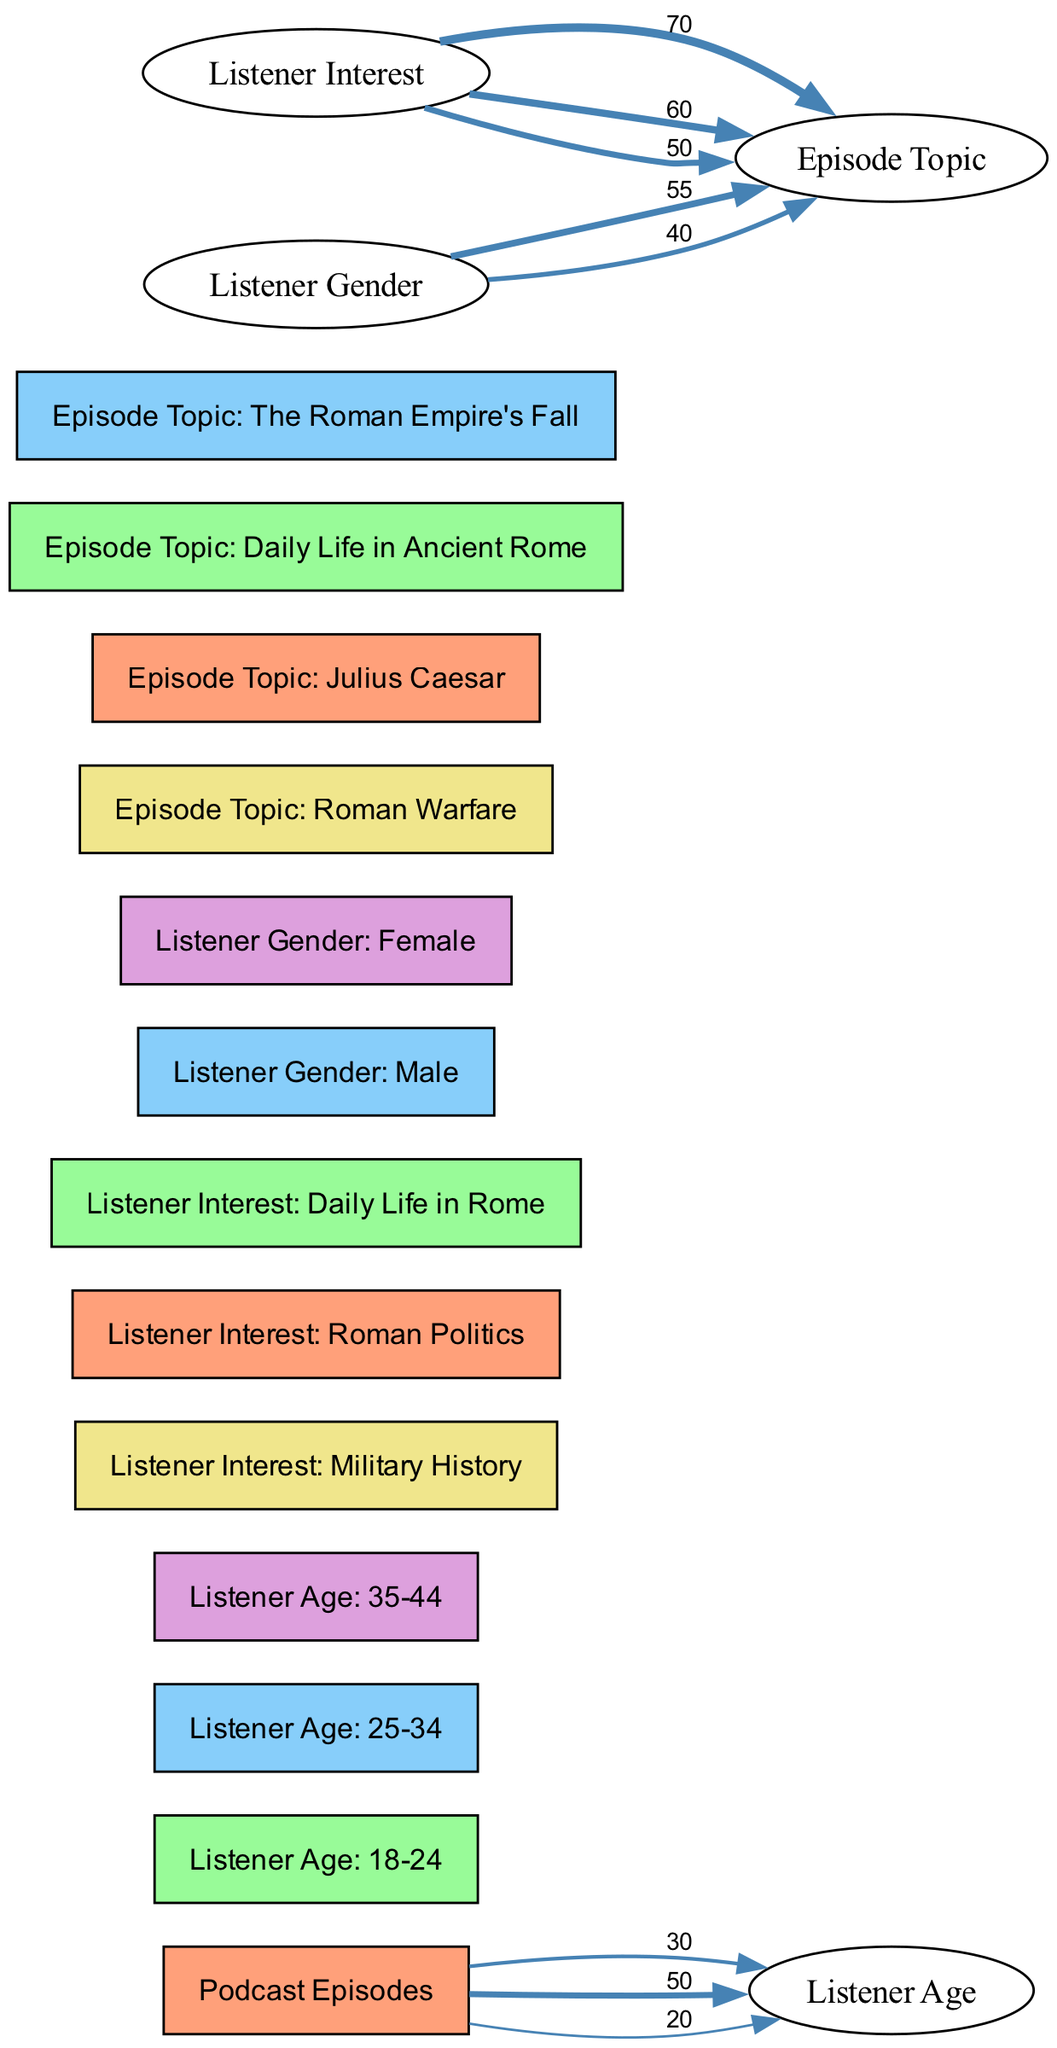What is the total number of listeners aged 25-34? The diagram shows a direct connection between "Podcast Episodes" and "Listener Age: 25-34", with a value of 50. Therefore, the total number of listeners in this age group is represented by this value.
Answer: 50 Which episode topic has the highest interest from listeners of military history? The flow from "Listener Interest: Military History" to "Episode Topic: Roman Warfare" has the highest value of 70, indicating that this episode topic attracts the most interest from military history listeners.
Answer: Roman Warfare What percentage of listeners aged 18-24 are interested in military history? To find out the percentage, first note the value of listeners aged 18-24 is 30 and the value from military history to Roman Warfare is 70. Since the total number of listeners is presumably the sum of several listener groups, we can typically estimate the interest by simply considering the age group value against the context. In this case, however, due to lack of absolute total listeners given, we can conclude from the diagram directly that not all listeners in any age group may be military history lovers, thus resulting in a descriptive observation rather than calculating a percentage.
Answer: Not determinable Which listener demographic is most interested in the topic "The Roman Empire's Fall"? Observing the flow from "Listener Gender: Male" to "Episode Topic: The Roman Empire's Fall" with a value of 55 indicates this gender group has the highest connection to the topic compared to the connection flows from other demographics.
Answer: Male What is the value linking "Listener Gender: Female" to "Episode Topic: Julius Caesar"? The link from "Listener Gender: Female" to "Episode Topic: Julius Caesar" has a value of 40, indicating the number of female listeners interested in that episode topic.
Answer: 40 Which age group has the least representation in the listener demographic? Focusing on the connections between "Podcast Episodes" and listener ages, the node "Listener Age: 35-44" has the lowest value of 20, indicating fewer listeners belonging to this age group.
Answer: 35-44 How does listener interest in "Daily Life in Rome" connect to episode preferences? The connection from "Listener Interest: Daily Life in Rome" to "Episode Topic: Daily Life in Ancient Rome" with a value of 50 shows a substantial interest in this topic among relevant listeners, indicating a direct preference link.
Answer: 50 How many episode topics are illustrated in the diagram? The diagram displays four distinct episode topics connected to listener interests, which can be counted from the nodes section or by observing discrete connections to listener interests.
Answer: 4 